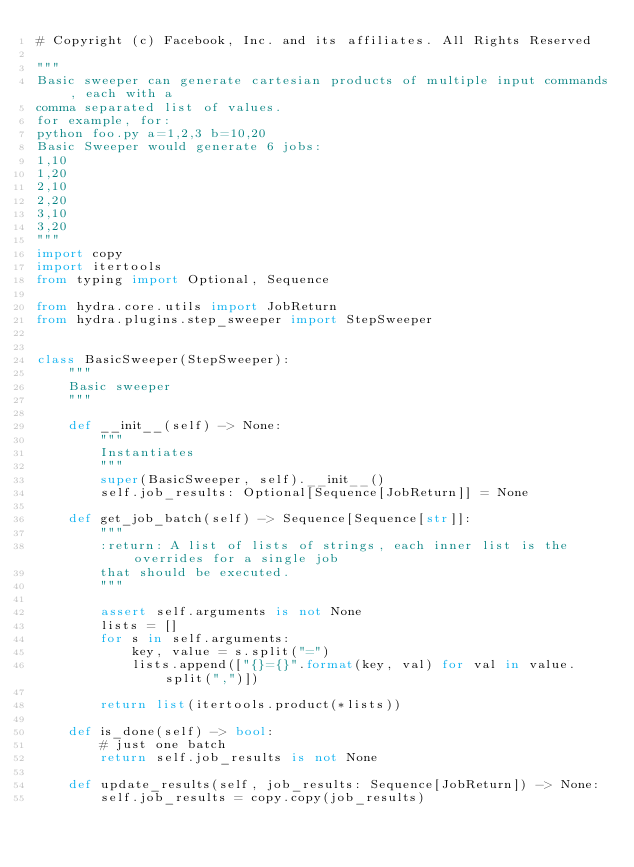Convert code to text. <code><loc_0><loc_0><loc_500><loc_500><_Python_># Copyright (c) Facebook, Inc. and its affiliates. All Rights Reserved

"""
Basic sweeper can generate cartesian products of multiple input commands, each with a
comma separated list of values.
for example, for:
python foo.py a=1,2,3 b=10,20
Basic Sweeper would generate 6 jobs:
1,10
1,20
2,10
2,20
3,10
3,20
"""
import copy
import itertools
from typing import Optional, Sequence

from hydra.core.utils import JobReturn
from hydra.plugins.step_sweeper import StepSweeper


class BasicSweeper(StepSweeper):
    """
    Basic sweeper
    """

    def __init__(self) -> None:
        """
        Instantiates
        """
        super(BasicSweeper, self).__init__()
        self.job_results: Optional[Sequence[JobReturn]] = None

    def get_job_batch(self) -> Sequence[Sequence[str]]:
        """
        :return: A list of lists of strings, each inner list is the overrides for a single job
        that should be executed.
        """

        assert self.arguments is not None
        lists = []
        for s in self.arguments:
            key, value = s.split("=")
            lists.append(["{}={}".format(key, val) for val in value.split(",")])

        return list(itertools.product(*lists))

    def is_done(self) -> bool:
        # just one batch
        return self.job_results is not None

    def update_results(self, job_results: Sequence[JobReturn]) -> None:
        self.job_results = copy.copy(job_results)
</code> 